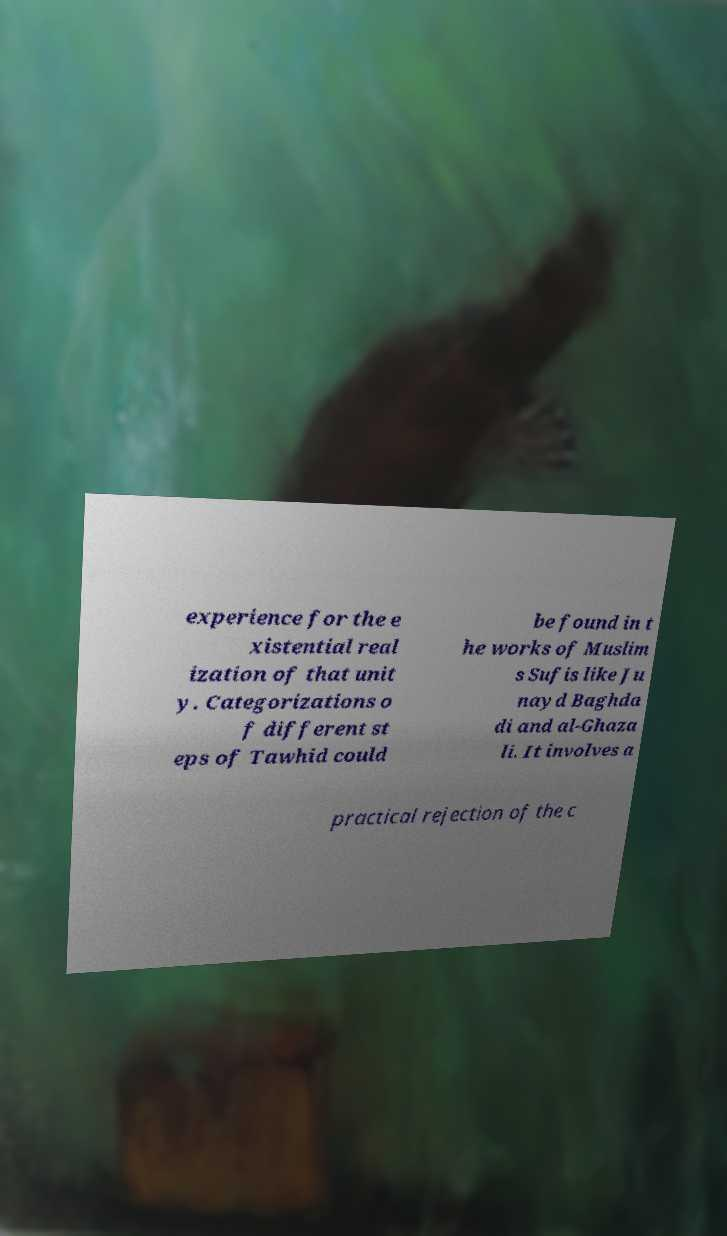Can you read and provide the text displayed in the image?This photo seems to have some interesting text. Can you extract and type it out for me? experience for the e xistential real ization of that unit y. Categorizations o f different st eps of Tawhid could be found in t he works of Muslim s Sufis like Ju nayd Baghda di and al-Ghaza li. It involves a practical rejection of the c 